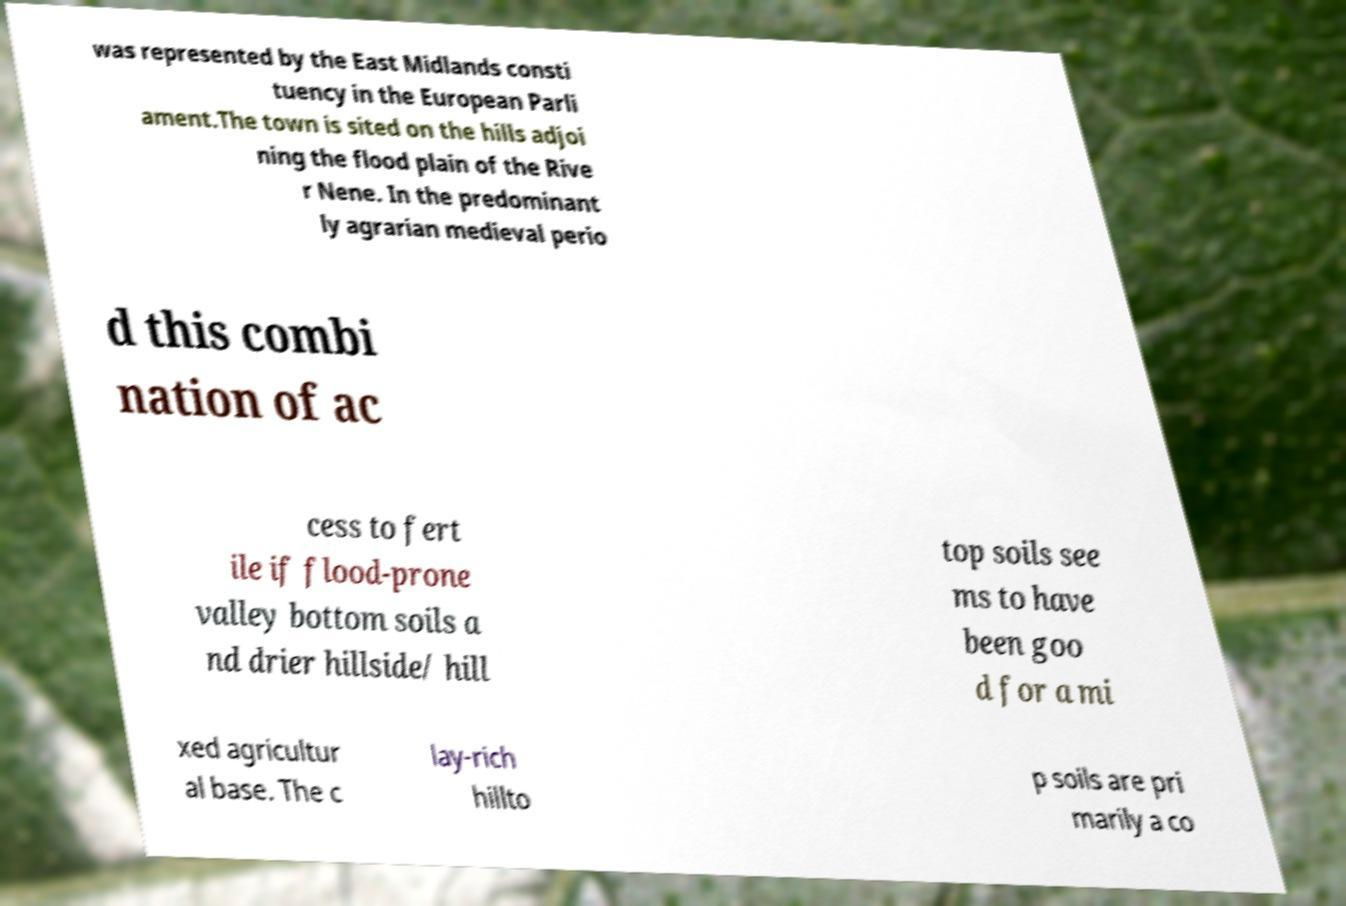There's text embedded in this image that I need extracted. Can you transcribe it verbatim? was represented by the East Midlands consti tuency in the European Parli ament.The town is sited on the hills adjoi ning the flood plain of the Rive r Nene. In the predominant ly agrarian medieval perio d this combi nation of ac cess to fert ile if flood-prone valley bottom soils a nd drier hillside/ hill top soils see ms to have been goo d for a mi xed agricultur al base. The c lay-rich hillto p soils are pri marily a co 